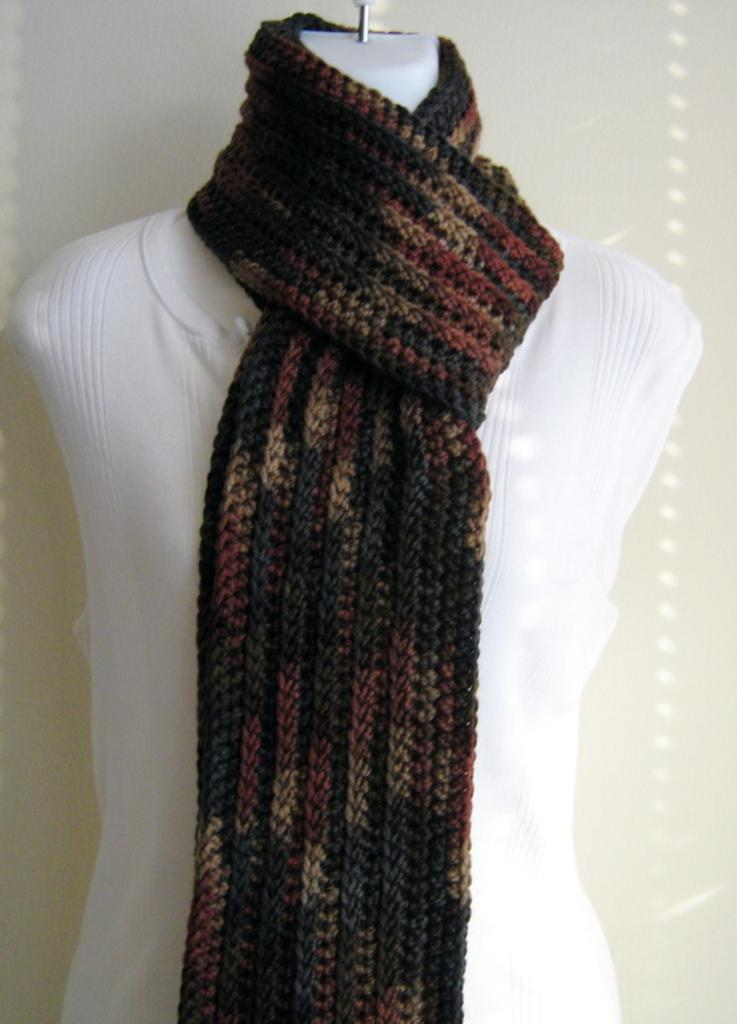What is the main subject of the image? There is a mannequin in the image. What is the mannequin wearing on its upper body? The mannequin is wearing a white t-shirt. What additional clothing item is the mannequin wearing? The mannequin is wearing a woolen stole. What type of riddle is the mannequin solving in the image? There is no riddle present in the image; it only features a mannequin wearing a white t-shirt and a woolen stole. 